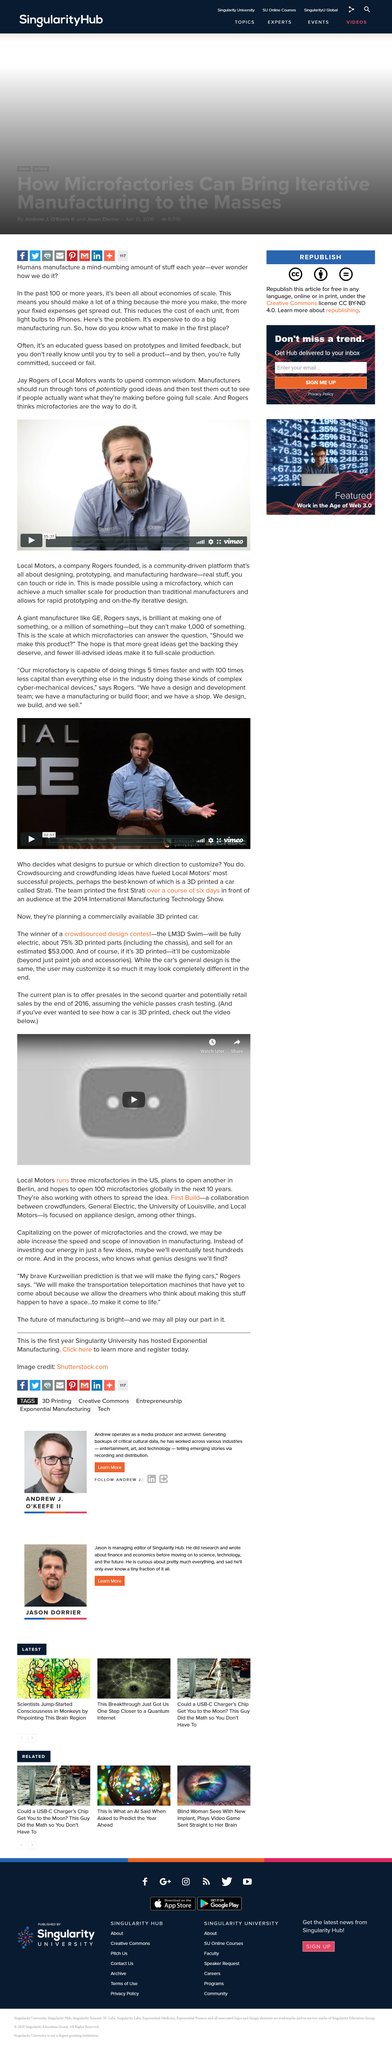Point out several critical features in this image. An educated guess is derived from prototypes and limited feedback. To reduce the cost of each unit, it is recommended that you manufacture more of the following items: [list of items]. By increasing production, you can take advantage of economies of scale and lower the cost of each unit manufactured. Yes, they have a design and development team that is planning to bring a commercially available 3D printed car to the market. The 3D printed car, known as Strati, has been the subject of much discussion and curiosity. Its name has now been announced. Rogers believes that manufacturers should conduct extensive testing of various promising ideas before fully implementing them. 